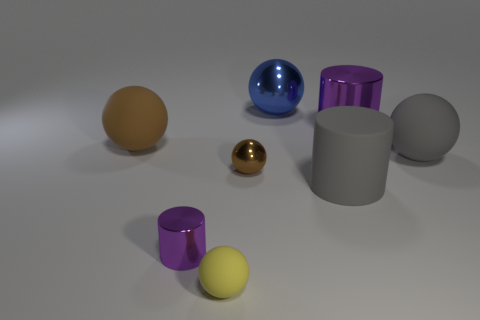How many objects are there in total in this scene? In total, there are eight objects in the scene. Could you describe the textures of the objects? Sure! The objects appear to have varying textures: the blue sphere has a reflective, glossy texture; the gold sphere is also reflective but appears smoother; the cylinders and the other spheres have matte finishes. 